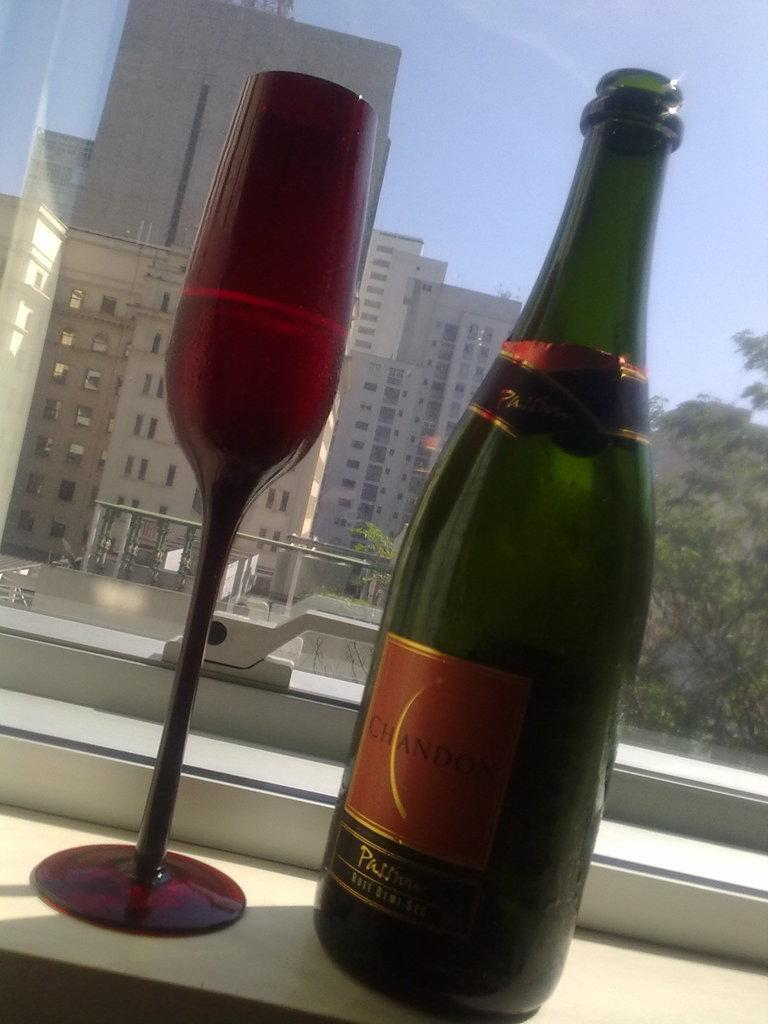What type of container is present in the image? There is a glass bottle in the image. What other glass object can be seen in the image? There is a glass object in the image. What type of structures are visible in the image? There are buildings visible in the image. What type of vegetation is present in the image? There is a tree in the image. What color is the sky in the image? The sky is blue in the image. What type of wave can be seen crashing on the shore in the image? There is no wave or shore present in the image; it features a glass bottle, a glass object, buildings, a tree, and a blue sky. What type of spoon is used to stir the contents of the glass object in the image? There is no spoon or stirring action present in the image; it only features a glass bottle and a glass object. 